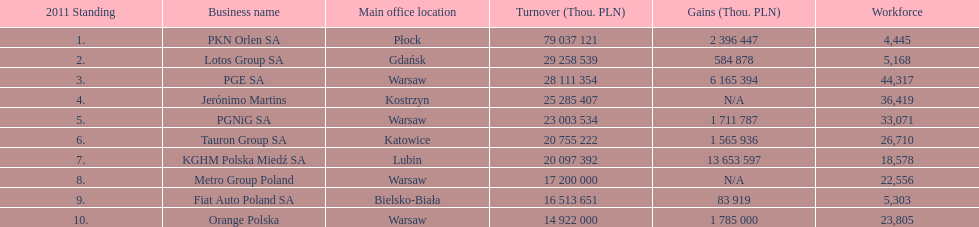Which company had the least revenue? Orange Polska. 